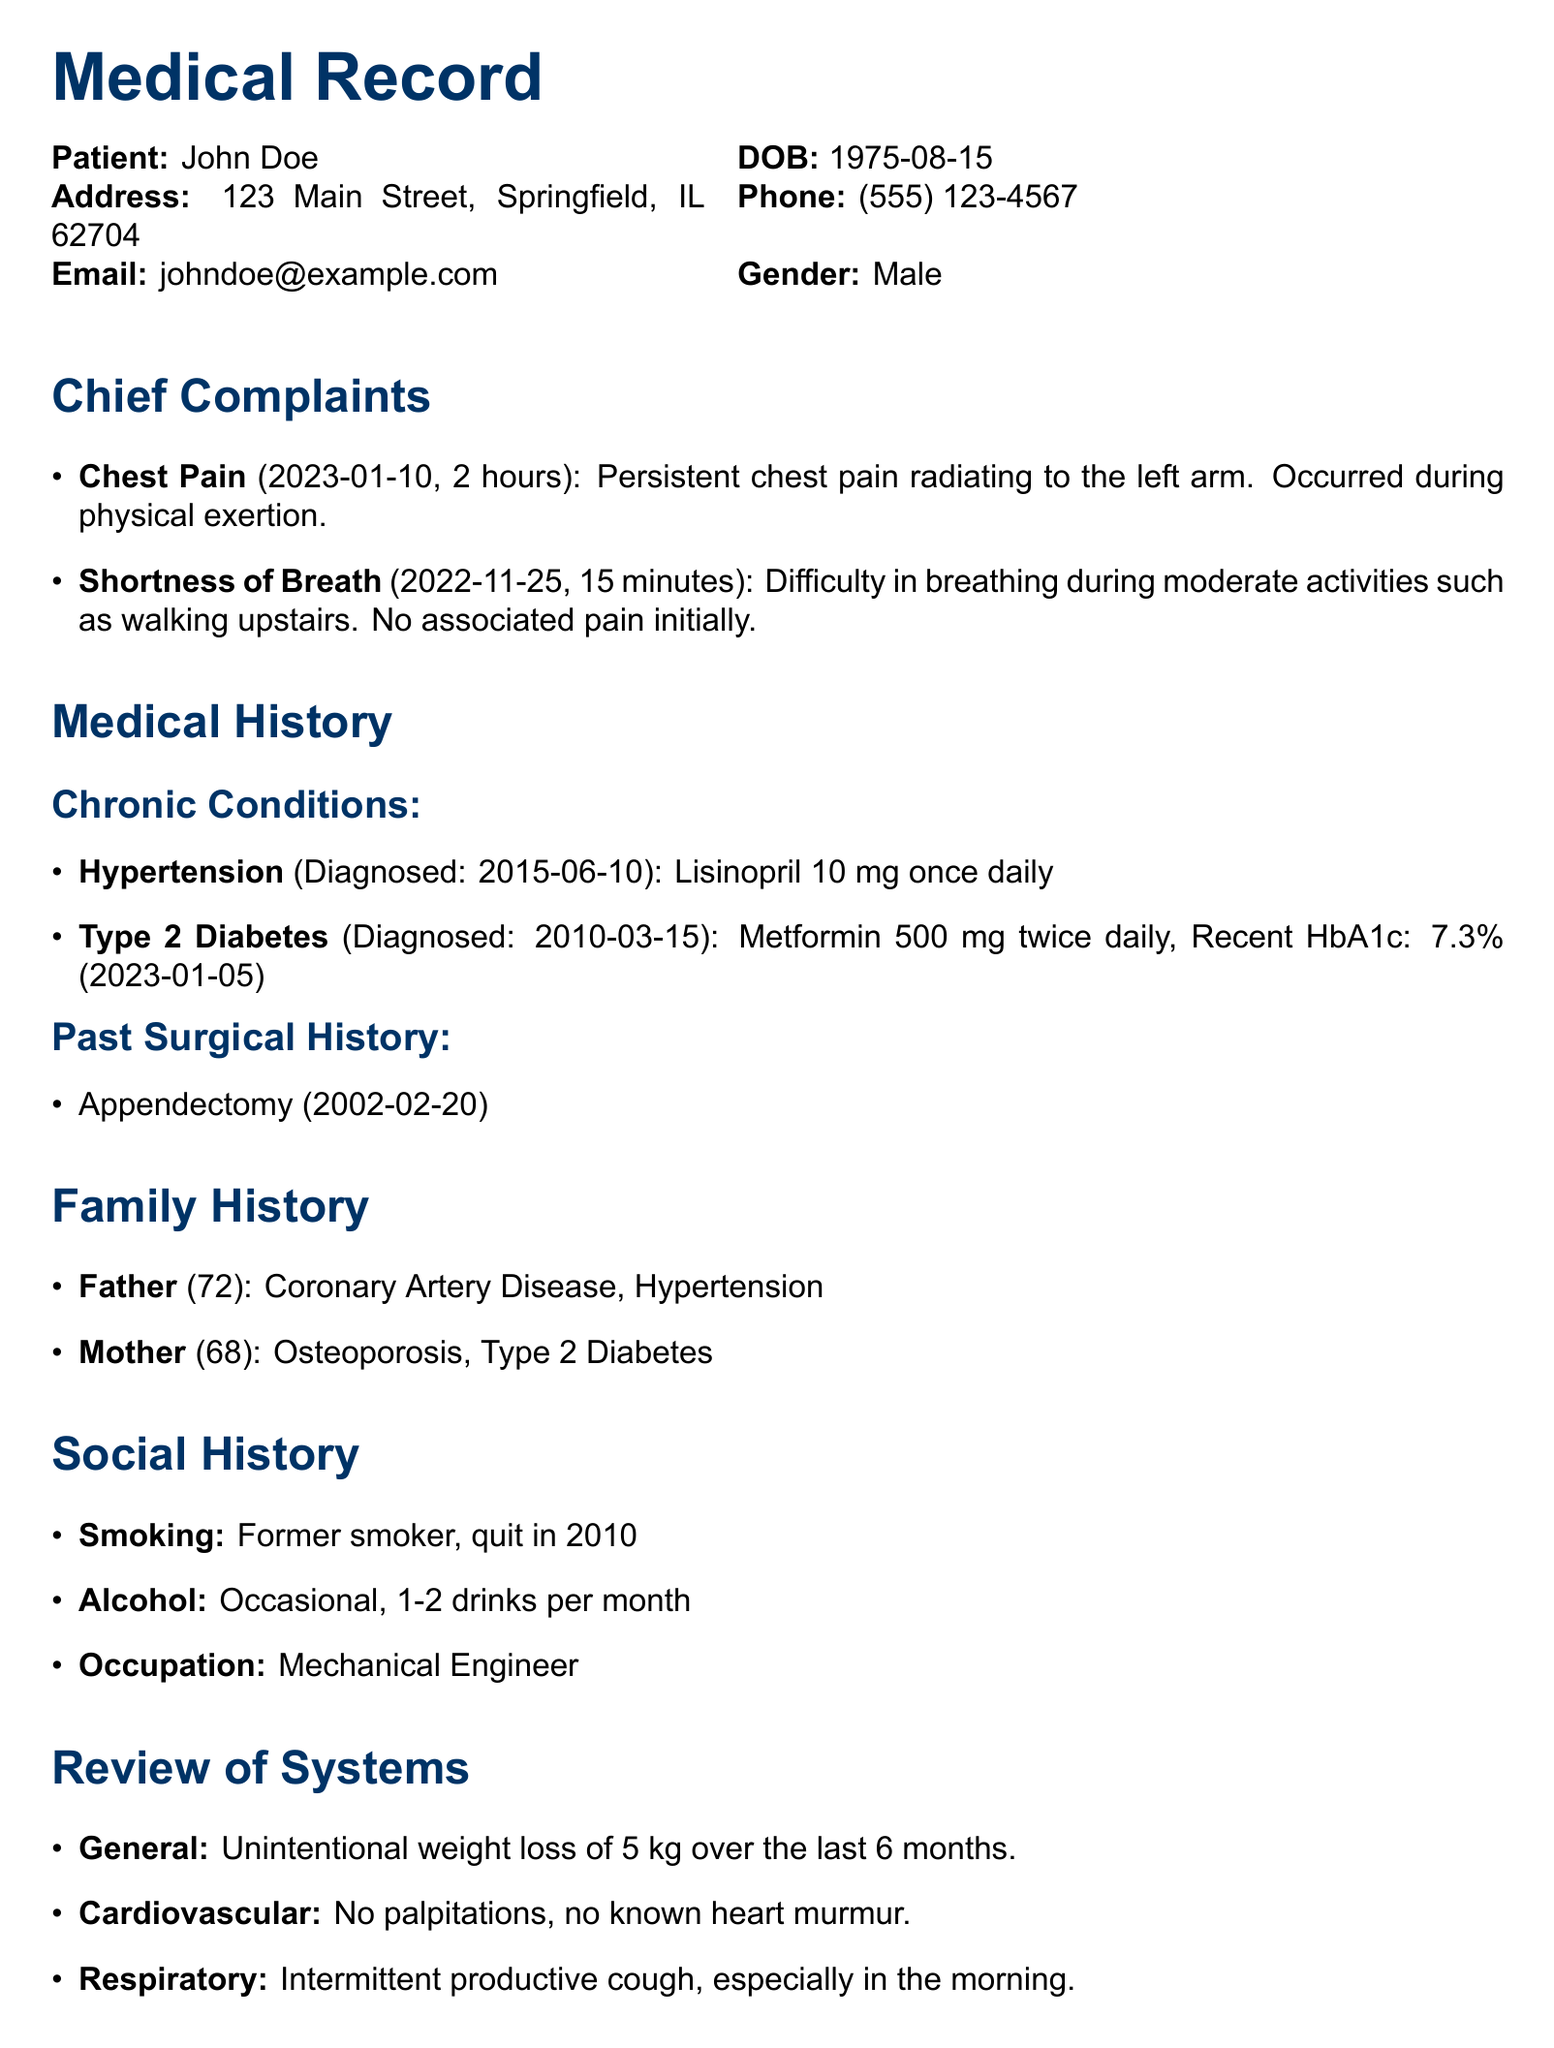What is the patient's name? The patient's name is listed at the top of the document under the patient details section.
Answer: John Doe What medication is prescribed for hypertension? The medication for hypertension is mentioned in the chronic conditions section of the document.
Answer: Lisinopril 10 mg once daily When was the appendectomy performed? The date of the appendectomy is found in the past surgical history section.
Answer: 2002-02-20 What was the patient's most recent HbA1c level? The most recent HbA1c level is listed in the chronic conditions section together with the diabetes diagnosis.
Answer: 7.3% How long has the patient been experiencing chest pain? The duration of the chest pain is provided in the chief complaints section, indicating how long the symptom lasted.
Answer: 2 hours What smoking status is noted in the social history? The social history discusses the patient's smoking habits, specifically the user's past smoking status.
Answer: Former smoker What were the vital signs for blood pressure? The blood pressure value is provided within the physical examination section of the document.
Answer: 150/90 mmHg What is the age of the patient's father? The age of the patient's father is presented in the family history section.
Answer: 72 